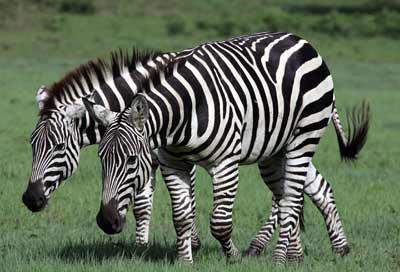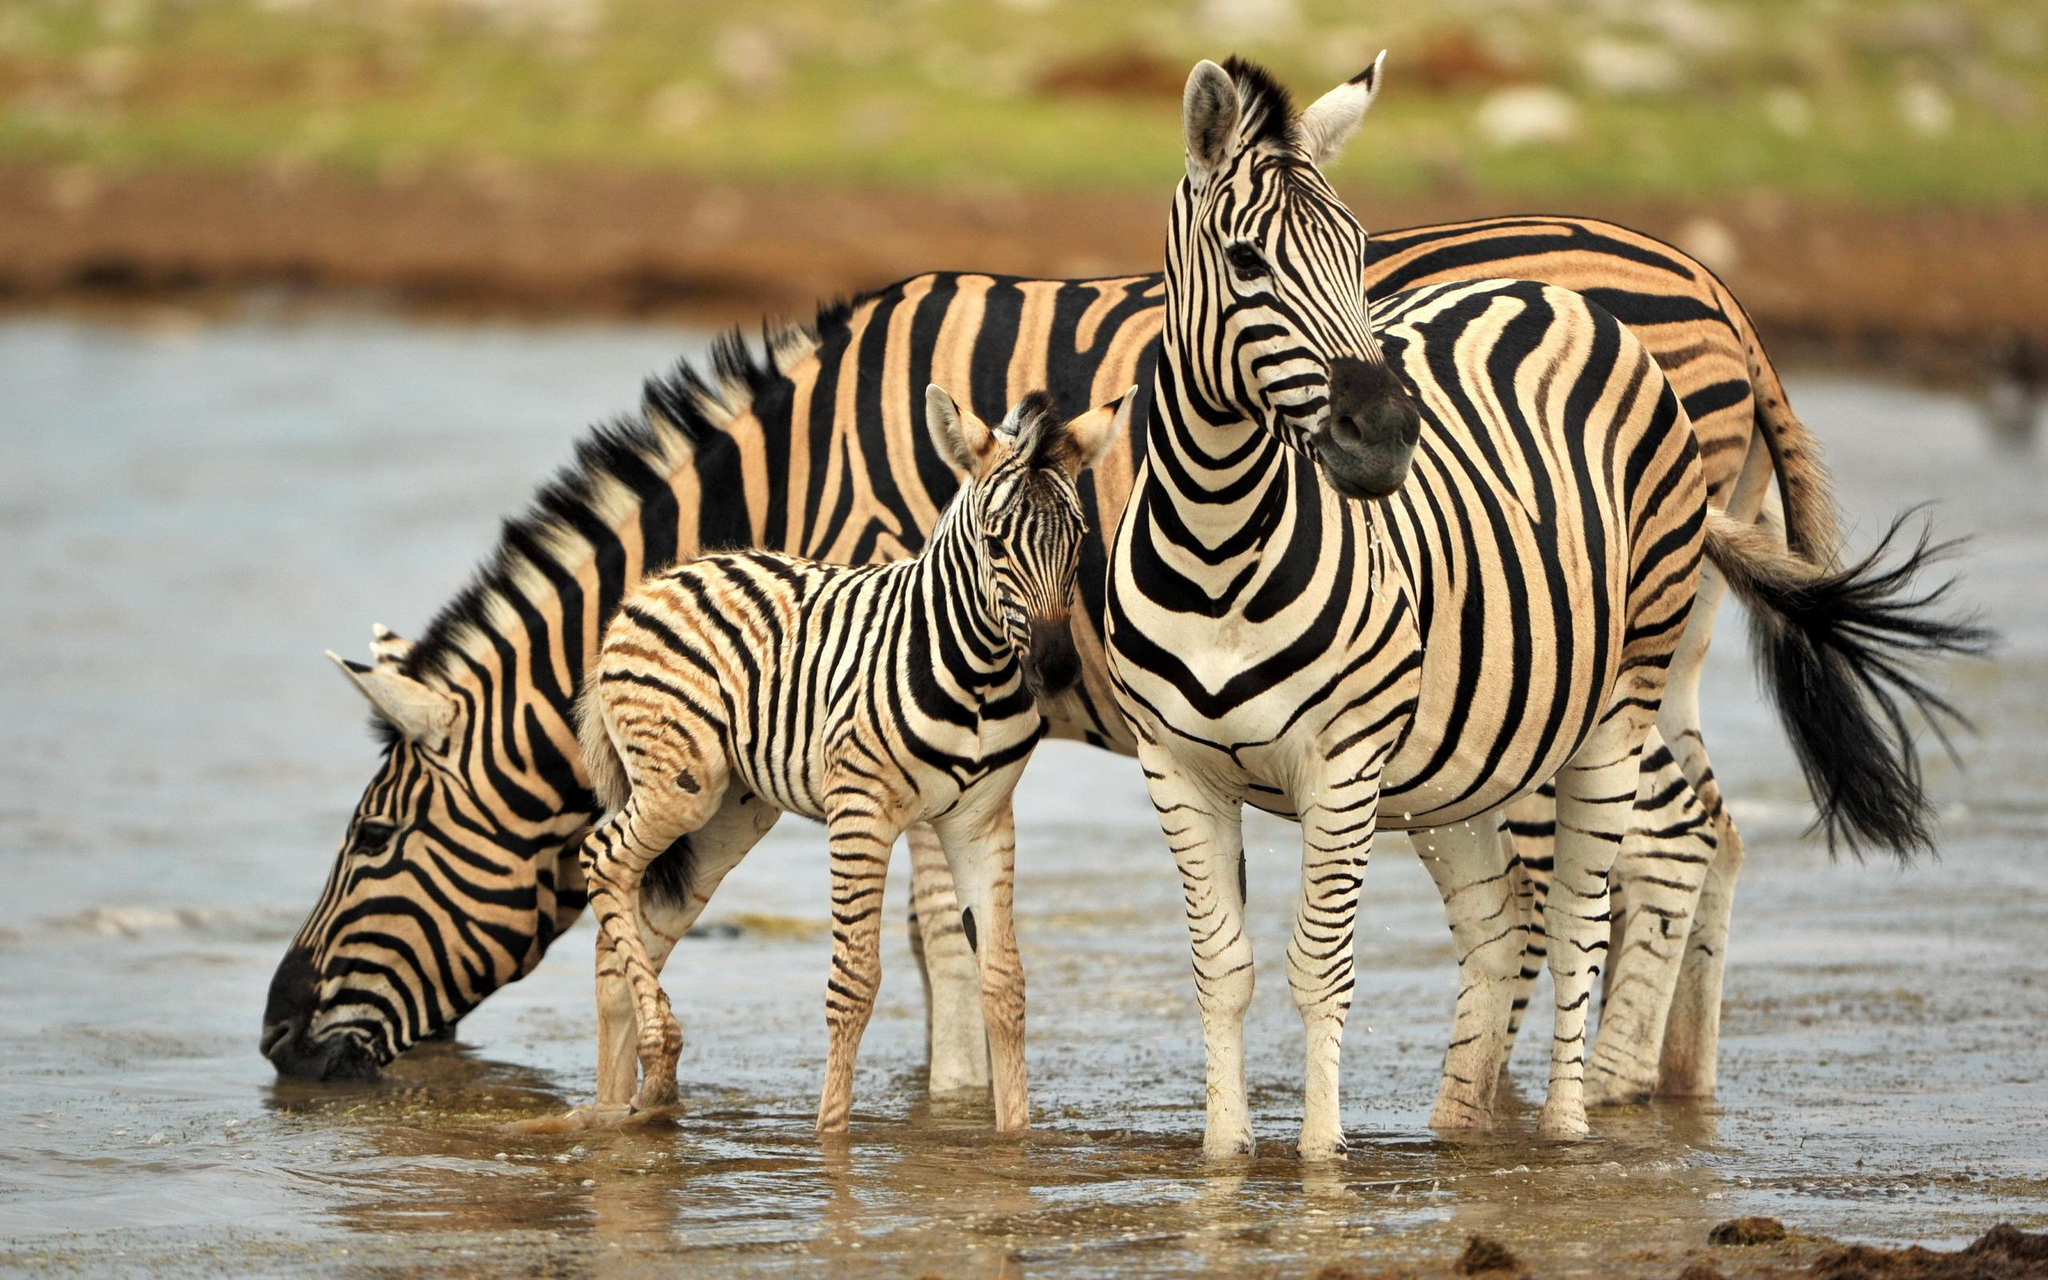The first image is the image on the left, the second image is the image on the right. Analyze the images presented: Is the assertion "A young zebra can be seen with at least one adult zebra in one of the images." valid? Answer yes or no. Yes. The first image is the image on the left, the second image is the image on the right. Evaluate the accuracy of this statement regarding the images: "In one image, two similarly-sized zebras are standing side by side in the same direction.". Is it true? Answer yes or no. Yes. 